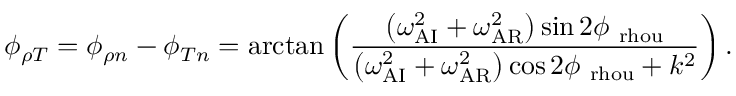<formula> <loc_0><loc_0><loc_500><loc_500>\phi _ { \rho T } = \phi _ { \rho n } - \phi _ { T n } = \arctan \left ( \frac { \left ( \omega _ { A I } ^ { 2 } + \omega _ { A R } ^ { 2 } \right ) \sin { 2 \phi _ { \ r h o u } } } { \left ( \omega _ { A I } ^ { 2 } + \omega _ { A R } ^ { 2 } \right ) \cos { 2 \phi _ { \ r h o u } } + k ^ { 2 } } \right ) .</formula> 